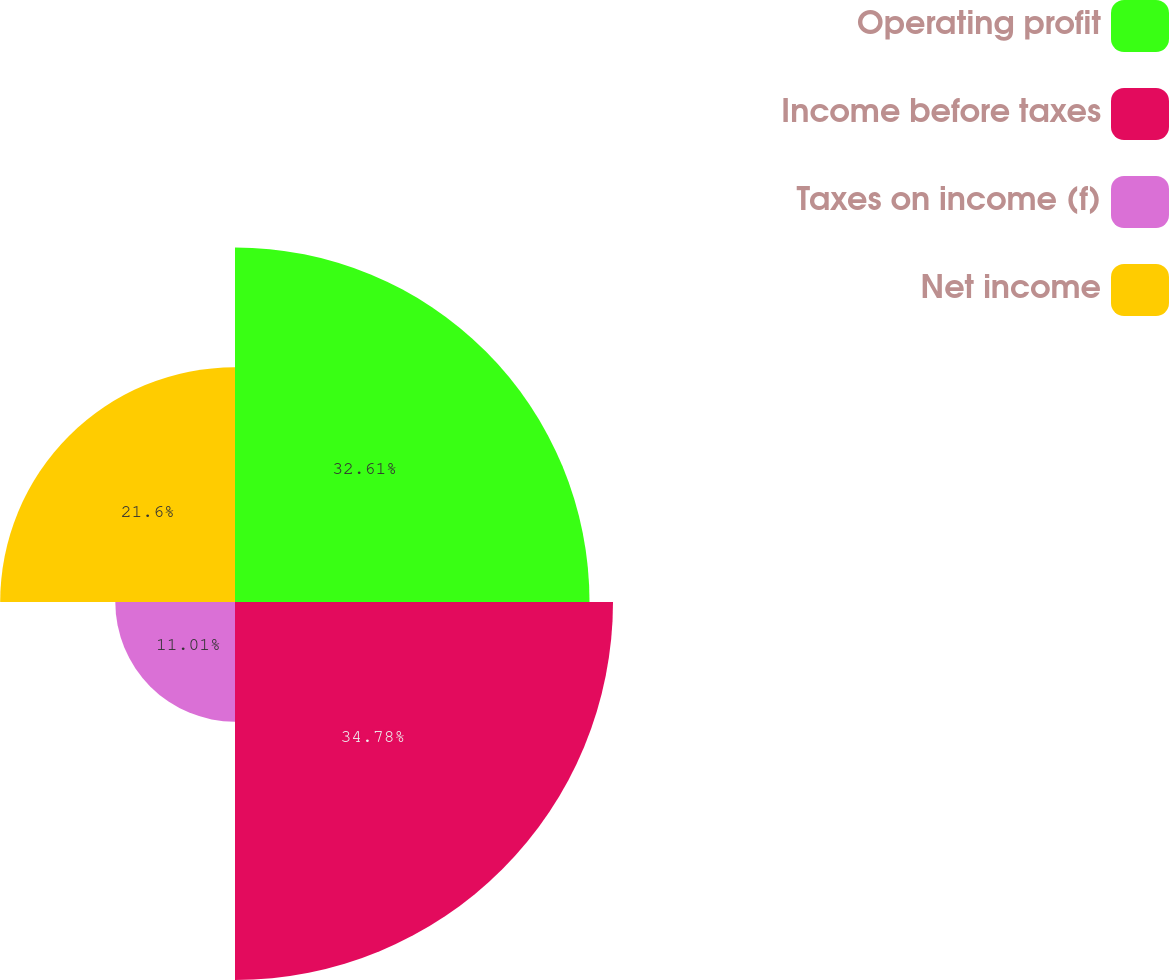Convert chart to OTSL. <chart><loc_0><loc_0><loc_500><loc_500><pie_chart><fcel>Operating profit<fcel>Income before taxes<fcel>Taxes on income (f)<fcel>Net income<nl><fcel>32.61%<fcel>34.77%<fcel>11.01%<fcel>21.6%<nl></chart> 